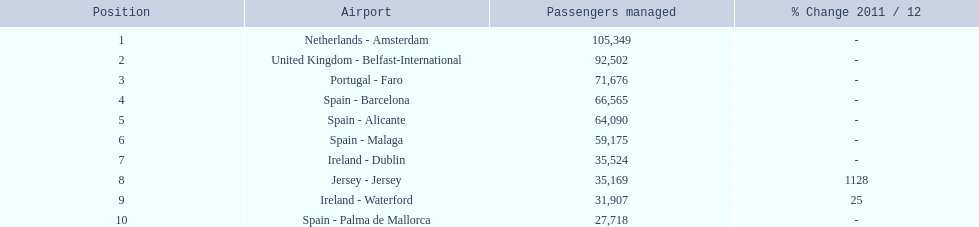What are the 10 busiest routes to and from london southend airport? Netherlands - Amsterdam, United Kingdom - Belfast-International, Portugal - Faro, Spain - Barcelona, Spain - Alicante, Spain - Malaga, Ireland - Dublin, Jersey - Jersey, Ireland - Waterford, Spain - Palma de Mallorca. Of these, which airport is in portugal? Portugal - Faro. 